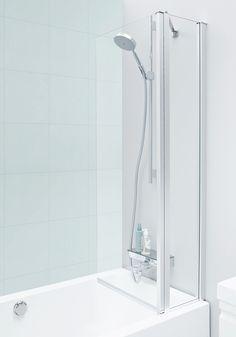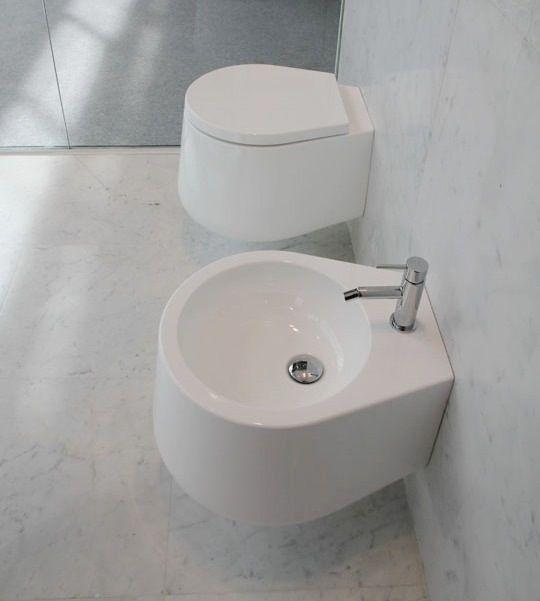The first image is the image on the left, the second image is the image on the right. Assess this claim about the two images: "In one image a sink with chrome faucet and a commode, both white, are mounted side by side on a wall.". Correct or not? Answer yes or no. Yes. The first image is the image on the left, the second image is the image on the right. Examine the images to the left and right. Is the description "The right image includes a tankless wall-mounted white toilet behind a similarly shaped wall-mounted white sink." accurate? Answer yes or no. Yes. 